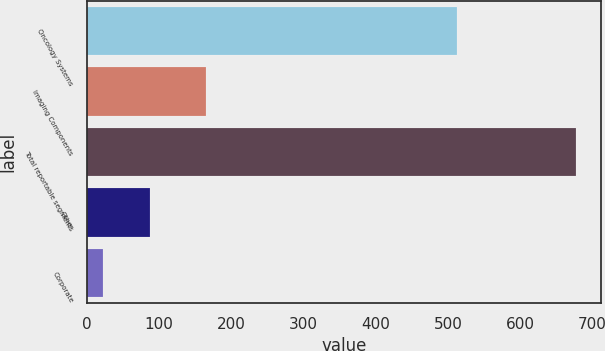Convert chart. <chart><loc_0><loc_0><loc_500><loc_500><bar_chart><fcel>Oncology Systems<fcel>Imaging Components<fcel>Total reportable segments<fcel>Other<fcel>Corporate<nl><fcel>512<fcel>165.6<fcel>677.6<fcel>87.83<fcel>22.3<nl></chart> 